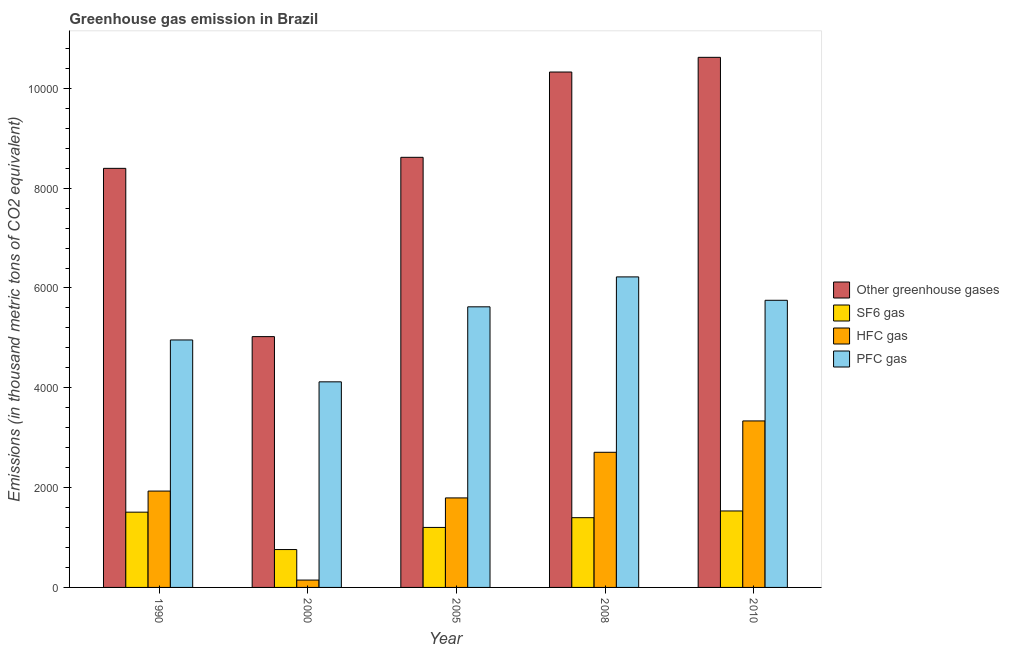How many different coloured bars are there?
Offer a terse response. 4. Are the number of bars per tick equal to the number of legend labels?
Ensure brevity in your answer.  Yes. What is the label of the 3rd group of bars from the left?
Your answer should be very brief. 2005. What is the emission of sf6 gas in 2010?
Your answer should be very brief. 1532. Across all years, what is the maximum emission of hfc gas?
Ensure brevity in your answer.  3336. Across all years, what is the minimum emission of pfc gas?
Your response must be concise. 4119.1. In which year was the emission of sf6 gas maximum?
Your answer should be compact. 2010. In which year was the emission of pfc gas minimum?
Ensure brevity in your answer.  2000. What is the total emission of hfc gas in the graph?
Keep it short and to the point. 9915. What is the difference between the emission of greenhouse gases in 2005 and that in 2008?
Keep it short and to the point. -1709.1. What is the difference between the emission of pfc gas in 1990 and the emission of greenhouse gases in 2000?
Provide a succinct answer. 839. What is the average emission of greenhouse gases per year?
Your answer should be compact. 8597.4. What is the ratio of the emission of hfc gas in 2008 to that in 2010?
Ensure brevity in your answer.  0.81. Is the difference between the emission of hfc gas in 1990 and 2008 greater than the difference between the emission of sf6 gas in 1990 and 2008?
Your response must be concise. No. What is the difference between the highest and the second highest emission of greenhouse gases?
Provide a short and direct response. 294.4. What is the difference between the highest and the lowest emission of sf6 gas?
Ensure brevity in your answer.  773.3. Is it the case that in every year, the sum of the emission of greenhouse gases and emission of hfc gas is greater than the sum of emission of pfc gas and emission of sf6 gas?
Keep it short and to the point. Yes. What does the 2nd bar from the left in 2008 represents?
Offer a terse response. SF6 gas. What does the 2nd bar from the right in 1990 represents?
Offer a very short reply. HFC gas. Is it the case that in every year, the sum of the emission of greenhouse gases and emission of sf6 gas is greater than the emission of hfc gas?
Your answer should be very brief. Yes. How many years are there in the graph?
Give a very brief answer. 5. What is the difference between two consecutive major ticks on the Y-axis?
Give a very brief answer. 2000. Are the values on the major ticks of Y-axis written in scientific E-notation?
Provide a short and direct response. No. Does the graph contain grids?
Offer a very short reply. No. Where does the legend appear in the graph?
Provide a succinct answer. Center right. How are the legend labels stacked?
Your answer should be very brief. Vertical. What is the title of the graph?
Your response must be concise. Greenhouse gas emission in Brazil. Does "Taxes on revenue" appear as one of the legend labels in the graph?
Your answer should be compact. No. What is the label or title of the Y-axis?
Provide a short and direct response. Emissions (in thousand metric tons of CO2 equivalent). What is the Emissions (in thousand metric tons of CO2 equivalent) of Other greenhouse gases in 1990?
Your answer should be very brief. 8396.7. What is the Emissions (in thousand metric tons of CO2 equivalent) of SF6 gas in 1990?
Offer a very short reply. 1507.9. What is the Emissions (in thousand metric tons of CO2 equivalent) of HFC gas in 1990?
Your answer should be compact. 1930.7. What is the Emissions (in thousand metric tons of CO2 equivalent) in PFC gas in 1990?
Your answer should be compact. 4958.1. What is the Emissions (in thousand metric tons of CO2 equivalent) of Other greenhouse gases in 2000?
Give a very brief answer. 5025.2. What is the Emissions (in thousand metric tons of CO2 equivalent) in SF6 gas in 2000?
Keep it short and to the point. 758.7. What is the Emissions (in thousand metric tons of CO2 equivalent) in HFC gas in 2000?
Your answer should be compact. 147.4. What is the Emissions (in thousand metric tons of CO2 equivalent) in PFC gas in 2000?
Your answer should be very brief. 4119.1. What is the Emissions (in thousand metric tons of CO2 equivalent) in Other greenhouse gases in 2005?
Your answer should be compact. 8617.5. What is the Emissions (in thousand metric tons of CO2 equivalent) of SF6 gas in 2005?
Your answer should be compact. 1202. What is the Emissions (in thousand metric tons of CO2 equivalent) in HFC gas in 2005?
Your answer should be compact. 1793.4. What is the Emissions (in thousand metric tons of CO2 equivalent) in PFC gas in 2005?
Provide a short and direct response. 5622.1. What is the Emissions (in thousand metric tons of CO2 equivalent) of Other greenhouse gases in 2008?
Give a very brief answer. 1.03e+04. What is the Emissions (in thousand metric tons of CO2 equivalent) of SF6 gas in 2008?
Your answer should be very brief. 1397.3. What is the Emissions (in thousand metric tons of CO2 equivalent) in HFC gas in 2008?
Your answer should be compact. 2707.5. What is the Emissions (in thousand metric tons of CO2 equivalent) of PFC gas in 2008?
Provide a succinct answer. 6221.8. What is the Emissions (in thousand metric tons of CO2 equivalent) in Other greenhouse gases in 2010?
Offer a very short reply. 1.06e+04. What is the Emissions (in thousand metric tons of CO2 equivalent) of SF6 gas in 2010?
Your response must be concise. 1532. What is the Emissions (in thousand metric tons of CO2 equivalent) of HFC gas in 2010?
Keep it short and to the point. 3336. What is the Emissions (in thousand metric tons of CO2 equivalent) in PFC gas in 2010?
Provide a short and direct response. 5753. Across all years, what is the maximum Emissions (in thousand metric tons of CO2 equivalent) in Other greenhouse gases?
Provide a succinct answer. 1.06e+04. Across all years, what is the maximum Emissions (in thousand metric tons of CO2 equivalent) of SF6 gas?
Keep it short and to the point. 1532. Across all years, what is the maximum Emissions (in thousand metric tons of CO2 equivalent) in HFC gas?
Offer a terse response. 3336. Across all years, what is the maximum Emissions (in thousand metric tons of CO2 equivalent) in PFC gas?
Your answer should be compact. 6221.8. Across all years, what is the minimum Emissions (in thousand metric tons of CO2 equivalent) in Other greenhouse gases?
Provide a short and direct response. 5025.2. Across all years, what is the minimum Emissions (in thousand metric tons of CO2 equivalent) of SF6 gas?
Offer a very short reply. 758.7. Across all years, what is the minimum Emissions (in thousand metric tons of CO2 equivalent) in HFC gas?
Your response must be concise. 147.4. Across all years, what is the minimum Emissions (in thousand metric tons of CO2 equivalent) in PFC gas?
Keep it short and to the point. 4119.1. What is the total Emissions (in thousand metric tons of CO2 equivalent) of Other greenhouse gases in the graph?
Make the answer very short. 4.30e+04. What is the total Emissions (in thousand metric tons of CO2 equivalent) of SF6 gas in the graph?
Offer a terse response. 6397.9. What is the total Emissions (in thousand metric tons of CO2 equivalent) of HFC gas in the graph?
Offer a very short reply. 9915. What is the total Emissions (in thousand metric tons of CO2 equivalent) of PFC gas in the graph?
Provide a succinct answer. 2.67e+04. What is the difference between the Emissions (in thousand metric tons of CO2 equivalent) of Other greenhouse gases in 1990 and that in 2000?
Provide a short and direct response. 3371.5. What is the difference between the Emissions (in thousand metric tons of CO2 equivalent) of SF6 gas in 1990 and that in 2000?
Give a very brief answer. 749.2. What is the difference between the Emissions (in thousand metric tons of CO2 equivalent) in HFC gas in 1990 and that in 2000?
Give a very brief answer. 1783.3. What is the difference between the Emissions (in thousand metric tons of CO2 equivalent) of PFC gas in 1990 and that in 2000?
Provide a succinct answer. 839. What is the difference between the Emissions (in thousand metric tons of CO2 equivalent) of Other greenhouse gases in 1990 and that in 2005?
Your answer should be compact. -220.8. What is the difference between the Emissions (in thousand metric tons of CO2 equivalent) of SF6 gas in 1990 and that in 2005?
Ensure brevity in your answer.  305.9. What is the difference between the Emissions (in thousand metric tons of CO2 equivalent) in HFC gas in 1990 and that in 2005?
Offer a very short reply. 137.3. What is the difference between the Emissions (in thousand metric tons of CO2 equivalent) of PFC gas in 1990 and that in 2005?
Keep it short and to the point. -664. What is the difference between the Emissions (in thousand metric tons of CO2 equivalent) of Other greenhouse gases in 1990 and that in 2008?
Make the answer very short. -1929.9. What is the difference between the Emissions (in thousand metric tons of CO2 equivalent) of SF6 gas in 1990 and that in 2008?
Offer a terse response. 110.6. What is the difference between the Emissions (in thousand metric tons of CO2 equivalent) of HFC gas in 1990 and that in 2008?
Your answer should be very brief. -776.8. What is the difference between the Emissions (in thousand metric tons of CO2 equivalent) in PFC gas in 1990 and that in 2008?
Offer a terse response. -1263.7. What is the difference between the Emissions (in thousand metric tons of CO2 equivalent) in Other greenhouse gases in 1990 and that in 2010?
Provide a succinct answer. -2224.3. What is the difference between the Emissions (in thousand metric tons of CO2 equivalent) in SF6 gas in 1990 and that in 2010?
Your answer should be compact. -24.1. What is the difference between the Emissions (in thousand metric tons of CO2 equivalent) in HFC gas in 1990 and that in 2010?
Make the answer very short. -1405.3. What is the difference between the Emissions (in thousand metric tons of CO2 equivalent) of PFC gas in 1990 and that in 2010?
Make the answer very short. -794.9. What is the difference between the Emissions (in thousand metric tons of CO2 equivalent) in Other greenhouse gases in 2000 and that in 2005?
Ensure brevity in your answer.  -3592.3. What is the difference between the Emissions (in thousand metric tons of CO2 equivalent) in SF6 gas in 2000 and that in 2005?
Offer a very short reply. -443.3. What is the difference between the Emissions (in thousand metric tons of CO2 equivalent) in HFC gas in 2000 and that in 2005?
Offer a terse response. -1646. What is the difference between the Emissions (in thousand metric tons of CO2 equivalent) in PFC gas in 2000 and that in 2005?
Offer a very short reply. -1503. What is the difference between the Emissions (in thousand metric tons of CO2 equivalent) in Other greenhouse gases in 2000 and that in 2008?
Your response must be concise. -5301.4. What is the difference between the Emissions (in thousand metric tons of CO2 equivalent) in SF6 gas in 2000 and that in 2008?
Keep it short and to the point. -638.6. What is the difference between the Emissions (in thousand metric tons of CO2 equivalent) of HFC gas in 2000 and that in 2008?
Provide a short and direct response. -2560.1. What is the difference between the Emissions (in thousand metric tons of CO2 equivalent) of PFC gas in 2000 and that in 2008?
Your response must be concise. -2102.7. What is the difference between the Emissions (in thousand metric tons of CO2 equivalent) of Other greenhouse gases in 2000 and that in 2010?
Your answer should be very brief. -5595.8. What is the difference between the Emissions (in thousand metric tons of CO2 equivalent) of SF6 gas in 2000 and that in 2010?
Make the answer very short. -773.3. What is the difference between the Emissions (in thousand metric tons of CO2 equivalent) in HFC gas in 2000 and that in 2010?
Ensure brevity in your answer.  -3188.6. What is the difference between the Emissions (in thousand metric tons of CO2 equivalent) in PFC gas in 2000 and that in 2010?
Ensure brevity in your answer.  -1633.9. What is the difference between the Emissions (in thousand metric tons of CO2 equivalent) of Other greenhouse gases in 2005 and that in 2008?
Your answer should be compact. -1709.1. What is the difference between the Emissions (in thousand metric tons of CO2 equivalent) in SF6 gas in 2005 and that in 2008?
Ensure brevity in your answer.  -195.3. What is the difference between the Emissions (in thousand metric tons of CO2 equivalent) in HFC gas in 2005 and that in 2008?
Ensure brevity in your answer.  -914.1. What is the difference between the Emissions (in thousand metric tons of CO2 equivalent) of PFC gas in 2005 and that in 2008?
Your answer should be compact. -599.7. What is the difference between the Emissions (in thousand metric tons of CO2 equivalent) in Other greenhouse gases in 2005 and that in 2010?
Offer a terse response. -2003.5. What is the difference between the Emissions (in thousand metric tons of CO2 equivalent) in SF6 gas in 2005 and that in 2010?
Your answer should be very brief. -330. What is the difference between the Emissions (in thousand metric tons of CO2 equivalent) of HFC gas in 2005 and that in 2010?
Give a very brief answer. -1542.6. What is the difference between the Emissions (in thousand metric tons of CO2 equivalent) in PFC gas in 2005 and that in 2010?
Keep it short and to the point. -130.9. What is the difference between the Emissions (in thousand metric tons of CO2 equivalent) of Other greenhouse gases in 2008 and that in 2010?
Your response must be concise. -294.4. What is the difference between the Emissions (in thousand metric tons of CO2 equivalent) of SF6 gas in 2008 and that in 2010?
Your answer should be compact. -134.7. What is the difference between the Emissions (in thousand metric tons of CO2 equivalent) in HFC gas in 2008 and that in 2010?
Your answer should be compact. -628.5. What is the difference between the Emissions (in thousand metric tons of CO2 equivalent) in PFC gas in 2008 and that in 2010?
Keep it short and to the point. 468.8. What is the difference between the Emissions (in thousand metric tons of CO2 equivalent) in Other greenhouse gases in 1990 and the Emissions (in thousand metric tons of CO2 equivalent) in SF6 gas in 2000?
Your answer should be very brief. 7638. What is the difference between the Emissions (in thousand metric tons of CO2 equivalent) of Other greenhouse gases in 1990 and the Emissions (in thousand metric tons of CO2 equivalent) of HFC gas in 2000?
Your answer should be compact. 8249.3. What is the difference between the Emissions (in thousand metric tons of CO2 equivalent) in Other greenhouse gases in 1990 and the Emissions (in thousand metric tons of CO2 equivalent) in PFC gas in 2000?
Keep it short and to the point. 4277.6. What is the difference between the Emissions (in thousand metric tons of CO2 equivalent) of SF6 gas in 1990 and the Emissions (in thousand metric tons of CO2 equivalent) of HFC gas in 2000?
Your response must be concise. 1360.5. What is the difference between the Emissions (in thousand metric tons of CO2 equivalent) of SF6 gas in 1990 and the Emissions (in thousand metric tons of CO2 equivalent) of PFC gas in 2000?
Offer a terse response. -2611.2. What is the difference between the Emissions (in thousand metric tons of CO2 equivalent) in HFC gas in 1990 and the Emissions (in thousand metric tons of CO2 equivalent) in PFC gas in 2000?
Ensure brevity in your answer.  -2188.4. What is the difference between the Emissions (in thousand metric tons of CO2 equivalent) of Other greenhouse gases in 1990 and the Emissions (in thousand metric tons of CO2 equivalent) of SF6 gas in 2005?
Keep it short and to the point. 7194.7. What is the difference between the Emissions (in thousand metric tons of CO2 equivalent) of Other greenhouse gases in 1990 and the Emissions (in thousand metric tons of CO2 equivalent) of HFC gas in 2005?
Ensure brevity in your answer.  6603.3. What is the difference between the Emissions (in thousand metric tons of CO2 equivalent) of Other greenhouse gases in 1990 and the Emissions (in thousand metric tons of CO2 equivalent) of PFC gas in 2005?
Your response must be concise. 2774.6. What is the difference between the Emissions (in thousand metric tons of CO2 equivalent) in SF6 gas in 1990 and the Emissions (in thousand metric tons of CO2 equivalent) in HFC gas in 2005?
Your answer should be compact. -285.5. What is the difference between the Emissions (in thousand metric tons of CO2 equivalent) of SF6 gas in 1990 and the Emissions (in thousand metric tons of CO2 equivalent) of PFC gas in 2005?
Your answer should be compact. -4114.2. What is the difference between the Emissions (in thousand metric tons of CO2 equivalent) in HFC gas in 1990 and the Emissions (in thousand metric tons of CO2 equivalent) in PFC gas in 2005?
Your answer should be very brief. -3691.4. What is the difference between the Emissions (in thousand metric tons of CO2 equivalent) in Other greenhouse gases in 1990 and the Emissions (in thousand metric tons of CO2 equivalent) in SF6 gas in 2008?
Your answer should be compact. 6999.4. What is the difference between the Emissions (in thousand metric tons of CO2 equivalent) in Other greenhouse gases in 1990 and the Emissions (in thousand metric tons of CO2 equivalent) in HFC gas in 2008?
Offer a terse response. 5689.2. What is the difference between the Emissions (in thousand metric tons of CO2 equivalent) of Other greenhouse gases in 1990 and the Emissions (in thousand metric tons of CO2 equivalent) of PFC gas in 2008?
Make the answer very short. 2174.9. What is the difference between the Emissions (in thousand metric tons of CO2 equivalent) in SF6 gas in 1990 and the Emissions (in thousand metric tons of CO2 equivalent) in HFC gas in 2008?
Your answer should be very brief. -1199.6. What is the difference between the Emissions (in thousand metric tons of CO2 equivalent) in SF6 gas in 1990 and the Emissions (in thousand metric tons of CO2 equivalent) in PFC gas in 2008?
Ensure brevity in your answer.  -4713.9. What is the difference between the Emissions (in thousand metric tons of CO2 equivalent) in HFC gas in 1990 and the Emissions (in thousand metric tons of CO2 equivalent) in PFC gas in 2008?
Offer a very short reply. -4291.1. What is the difference between the Emissions (in thousand metric tons of CO2 equivalent) in Other greenhouse gases in 1990 and the Emissions (in thousand metric tons of CO2 equivalent) in SF6 gas in 2010?
Keep it short and to the point. 6864.7. What is the difference between the Emissions (in thousand metric tons of CO2 equivalent) in Other greenhouse gases in 1990 and the Emissions (in thousand metric tons of CO2 equivalent) in HFC gas in 2010?
Your answer should be very brief. 5060.7. What is the difference between the Emissions (in thousand metric tons of CO2 equivalent) in Other greenhouse gases in 1990 and the Emissions (in thousand metric tons of CO2 equivalent) in PFC gas in 2010?
Offer a very short reply. 2643.7. What is the difference between the Emissions (in thousand metric tons of CO2 equivalent) in SF6 gas in 1990 and the Emissions (in thousand metric tons of CO2 equivalent) in HFC gas in 2010?
Offer a very short reply. -1828.1. What is the difference between the Emissions (in thousand metric tons of CO2 equivalent) of SF6 gas in 1990 and the Emissions (in thousand metric tons of CO2 equivalent) of PFC gas in 2010?
Provide a succinct answer. -4245.1. What is the difference between the Emissions (in thousand metric tons of CO2 equivalent) of HFC gas in 1990 and the Emissions (in thousand metric tons of CO2 equivalent) of PFC gas in 2010?
Your answer should be very brief. -3822.3. What is the difference between the Emissions (in thousand metric tons of CO2 equivalent) in Other greenhouse gases in 2000 and the Emissions (in thousand metric tons of CO2 equivalent) in SF6 gas in 2005?
Offer a very short reply. 3823.2. What is the difference between the Emissions (in thousand metric tons of CO2 equivalent) in Other greenhouse gases in 2000 and the Emissions (in thousand metric tons of CO2 equivalent) in HFC gas in 2005?
Give a very brief answer. 3231.8. What is the difference between the Emissions (in thousand metric tons of CO2 equivalent) of Other greenhouse gases in 2000 and the Emissions (in thousand metric tons of CO2 equivalent) of PFC gas in 2005?
Offer a very short reply. -596.9. What is the difference between the Emissions (in thousand metric tons of CO2 equivalent) of SF6 gas in 2000 and the Emissions (in thousand metric tons of CO2 equivalent) of HFC gas in 2005?
Provide a short and direct response. -1034.7. What is the difference between the Emissions (in thousand metric tons of CO2 equivalent) in SF6 gas in 2000 and the Emissions (in thousand metric tons of CO2 equivalent) in PFC gas in 2005?
Make the answer very short. -4863.4. What is the difference between the Emissions (in thousand metric tons of CO2 equivalent) in HFC gas in 2000 and the Emissions (in thousand metric tons of CO2 equivalent) in PFC gas in 2005?
Provide a succinct answer. -5474.7. What is the difference between the Emissions (in thousand metric tons of CO2 equivalent) of Other greenhouse gases in 2000 and the Emissions (in thousand metric tons of CO2 equivalent) of SF6 gas in 2008?
Your response must be concise. 3627.9. What is the difference between the Emissions (in thousand metric tons of CO2 equivalent) of Other greenhouse gases in 2000 and the Emissions (in thousand metric tons of CO2 equivalent) of HFC gas in 2008?
Provide a short and direct response. 2317.7. What is the difference between the Emissions (in thousand metric tons of CO2 equivalent) in Other greenhouse gases in 2000 and the Emissions (in thousand metric tons of CO2 equivalent) in PFC gas in 2008?
Your answer should be compact. -1196.6. What is the difference between the Emissions (in thousand metric tons of CO2 equivalent) of SF6 gas in 2000 and the Emissions (in thousand metric tons of CO2 equivalent) of HFC gas in 2008?
Make the answer very short. -1948.8. What is the difference between the Emissions (in thousand metric tons of CO2 equivalent) of SF6 gas in 2000 and the Emissions (in thousand metric tons of CO2 equivalent) of PFC gas in 2008?
Your response must be concise. -5463.1. What is the difference between the Emissions (in thousand metric tons of CO2 equivalent) in HFC gas in 2000 and the Emissions (in thousand metric tons of CO2 equivalent) in PFC gas in 2008?
Offer a very short reply. -6074.4. What is the difference between the Emissions (in thousand metric tons of CO2 equivalent) of Other greenhouse gases in 2000 and the Emissions (in thousand metric tons of CO2 equivalent) of SF6 gas in 2010?
Give a very brief answer. 3493.2. What is the difference between the Emissions (in thousand metric tons of CO2 equivalent) of Other greenhouse gases in 2000 and the Emissions (in thousand metric tons of CO2 equivalent) of HFC gas in 2010?
Offer a terse response. 1689.2. What is the difference between the Emissions (in thousand metric tons of CO2 equivalent) of Other greenhouse gases in 2000 and the Emissions (in thousand metric tons of CO2 equivalent) of PFC gas in 2010?
Give a very brief answer. -727.8. What is the difference between the Emissions (in thousand metric tons of CO2 equivalent) in SF6 gas in 2000 and the Emissions (in thousand metric tons of CO2 equivalent) in HFC gas in 2010?
Offer a very short reply. -2577.3. What is the difference between the Emissions (in thousand metric tons of CO2 equivalent) in SF6 gas in 2000 and the Emissions (in thousand metric tons of CO2 equivalent) in PFC gas in 2010?
Keep it short and to the point. -4994.3. What is the difference between the Emissions (in thousand metric tons of CO2 equivalent) in HFC gas in 2000 and the Emissions (in thousand metric tons of CO2 equivalent) in PFC gas in 2010?
Your answer should be compact. -5605.6. What is the difference between the Emissions (in thousand metric tons of CO2 equivalent) in Other greenhouse gases in 2005 and the Emissions (in thousand metric tons of CO2 equivalent) in SF6 gas in 2008?
Offer a terse response. 7220.2. What is the difference between the Emissions (in thousand metric tons of CO2 equivalent) in Other greenhouse gases in 2005 and the Emissions (in thousand metric tons of CO2 equivalent) in HFC gas in 2008?
Offer a very short reply. 5910. What is the difference between the Emissions (in thousand metric tons of CO2 equivalent) of Other greenhouse gases in 2005 and the Emissions (in thousand metric tons of CO2 equivalent) of PFC gas in 2008?
Ensure brevity in your answer.  2395.7. What is the difference between the Emissions (in thousand metric tons of CO2 equivalent) of SF6 gas in 2005 and the Emissions (in thousand metric tons of CO2 equivalent) of HFC gas in 2008?
Your response must be concise. -1505.5. What is the difference between the Emissions (in thousand metric tons of CO2 equivalent) in SF6 gas in 2005 and the Emissions (in thousand metric tons of CO2 equivalent) in PFC gas in 2008?
Ensure brevity in your answer.  -5019.8. What is the difference between the Emissions (in thousand metric tons of CO2 equivalent) in HFC gas in 2005 and the Emissions (in thousand metric tons of CO2 equivalent) in PFC gas in 2008?
Make the answer very short. -4428.4. What is the difference between the Emissions (in thousand metric tons of CO2 equivalent) in Other greenhouse gases in 2005 and the Emissions (in thousand metric tons of CO2 equivalent) in SF6 gas in 2010?
Offer a very short reply. 7085.5. What is the difference between the Emissions (in thousand metric tons of CO2 equivalent) in Other greenhouse gases in 2005 and the Emissions (in thousand metric tons of CO2 equivalent) in HFC gas in 2010?
Provide a short and direct response. 5281.5. What is the difference between the Emissions (in thousand metric tons of CO2 equivalent) of Other greenhouse gases in 2005 and the Emissions (in thousand metric tons of CO2 equivalent) of PFC gas in 2010?
Ensure brevity in your answer.  2864.5. What is the difference between the Emissions (in thousand metric tons of CO2 equivalent) of SF6 gas in 2005 and the Emissions (in thousand metric tons of CO2 equivalent) of HFC gas in 2010?
Make the answer very short. -2134. What is the difference between the Emissions (in thousand metric tons of CO2 equivalent) of SF6 gas in 2005 and the Emissions (in thousand metric tons of CO2 equivalent) of PFC gas in 2010?
Your answer should be compact. -4551. What is the difference between the Emissions (in thousand metric tons of CO2 equivalent) of HFC gas in 2005 and the Emissions (in thousand metric tons of CO2 equivalent) of PFC gas in 2010?
Keep it short and to the point. -3959.6. What is the difference between the Emissions (in thousand metric tons of CO2 equivalent) of Other greenhouse gases in 2008 and the Emissions (in thousand metric tons of CO2 equivalent) of SF6 gas in 2010?
Ensure brevity in your answer.  8794.6. What is the difference between the Emissions (in thousand metric tons of CO2 equivalent) of Other greenhouse gases in 2008 and the Emissions (in thousand metric tons of CO2 equivalent) of HFC gas in 2010?
Ensure brevity in your answer.  6990.6. What is the difference between the Emissions (in thousand metric tons of CO2 equivalent) in Other greenhouse gases in 2008 and the Emissions (in thousand metric tons of CO2 equivalent) in PFC gas in 2010?
Your response must be concise. 4573.6. What is the difference between the Emissions (in thousand metric tons of CO2 equivalent) of SF6 gas in 2008 and the Emissions (in thousand metric tons of CO2 equivalent) of HFC gas in 2010?
Ensure brevity in your answer.  -1938.7. What is the difference between the Emissions (in thousand metric tons of CO2 equivalent) in SF6 gas in 2008 and the Emissions (in thousand metric tons of CO2 equivalent) in PFC gas in 2010?
Your response must be concise. -4355.7. What is the difference between the Emissions (in thousand metric tons of CO2 equivalent) of HFC gas in 2008 and the Emissions (in thousand metric tons of CO2 equivalent) of PFC gas in 2010?
Ensure brevity in your answer.  -3045.5. What is the average Emissions (in thousand metric tons of CO2 equivalent) in Other greenhouse gases per year?
Your response must be concise. 8597.4. What is the average Emissions (in thousand metric tons of CO2 equivalent) of SF6 gas per year?
Offer a terse response. 1279.58. What is the average Emissions (in thousand metric tons of CO2 equivalent) in HFC gas per year?
Give a very brief answer. 1983. What is the average Emissions (in thousand metric tons of CO2 equivalent) of PFC gas per year?
Your response must be concise. 5334.82. In the year 1990, what is the difference between the Emissions (in thousand metric tons of CO2 equivalent) in Other greenhouse gases and Emissions (in thousand metric tons of CO2 equivalent) in SF6 gas?
Give a very brief answer. 6888.8. In the year 1990, what is the difference between the Emissions (in thousand metric tons of CO2 equivalent) in Other greenhouse gases and Emissions (in thousand metric tons of CO2 equivalent) in HFC gas?
Offer a very short reply. 6466. In the year 1990, what is the difference between the Emissions (in thousand metric tons of CO2 equivalent) in Other greenhouse gases and Emissions (in thousand metric tons of CO2 equivalent) in PFC gas?
Provide a short and direct response. 3438.6. In the year 1990, what is the difference between the Emissions (in thousand metric tons of CO2 equivalent) in SF6 gas and Emissions (in thousand metric tons of CO2 equivalent) in HFC gas?
Your answer should be compact. -422.8. In the year 1990, what is the difference between the Emissions (in thousand metric tons of CO2 equivalent) in SF6 gas and Emissions (in thousand metric tons of CO2 equivalent) in PFC gas?
Your response must be concise. -3450.2. In the year 1990, what is the difference between the Emissions (in thousand metric tons of CO2 equivalent) in HFC gas and Emissions (in thousand metric tons of CO2 equivalent) in PFC gas?
Your answer should be very brief. -3027.4. In the year 2000, what is the difference between the Emissions (in thousand metric tons of CO2 equivalent) in Other greenhouse gases and Emissions (in thousand metric tons of CO2 equivalent) in SF6 gas?
Make the answer very short. 4266.5. In the year 2000, what is the difference between the Emissions (in thousand metric tons of CO2 equivalent) in Other greenhouse gases and Emissions (in thousand metric tons of CO2 equivalent) in HFC gas?
Keep it short and to the point. 4877.8. In the year 2000, what is the difference between the Emissions (in thousand metric tons of CO2 equivalent) in Other greenhouse gases and Emissions (in thousand metric tons of CO2 equivalent) in PFC gas?
Make the answer very short. 906.1. In the year 2000, what is the difference between the Emissions (in thousand metric tons of CO2 equivalent) in SF6 gas and Emissions (in thousand metric tons of CO2 equivalent) in HFC gas?
Ensure brevity in your answer.  611.3. In the year 2000, what is the difference between the Emissions (in thousand metric tons of CO2 equivalent) of SF6 gas and Emissions (in thousand metric tons of CO2 equivalent) of PFC gas?
Your answer should be compact. -3360.4. In the year 2000, what is the difference between the Emissions (in thousand metric tons of CO2 equivalent) of HFC gas and Emissions (in thousand metric tons of CO2 equivalent) of PFC gas?
Keep it short and to the point. -3971.7. In the year 2005, what is the difference between the Emissions (in thousand metric tons of CO2 equivalent) in Other greenhouse gases and Emissions (in thousand metric tons of CO2 equivalent) in SF6 gas?
Give a very brief answer. 7415.5. In the year 2005, what is the difference between the Emissions (in thousand metric tons of CO2 equivalent) in Other greenhouse gases and Emissions (in thousand metric tons of CO2 equivalent) in HFC gas?
Provide a short and direct response. 6824.1. In the year 2005, what is the difference between the Emissions (in thousand metric tons of CO2 equivalent) of Other greenhouse gases and Emissions (in thousand metric tons of CO2 equivalent) of PFC gas?
Provide a succinct answer. 2995.4. In the year 2005, what is the difference between the Emissions (in thousand metric tons of CO2 equivalent) in SF6 gas and Emissions (in thousand metric tons of CO2 equivalent) in HFC gas?
Ensure brevity in your answer.  -591.4. In the year 2005, what is the difference between the Emissions (in thousand metric tons of CO2 equivalent) of SF6 gas and Emissions (in thousand metric tons of CO2 equivalent) of PFC gas?
Your response must be concise. -4420.1. In the year 2005, what is the difference between the Emissions (in thousand metric tons of CO2 equivalent) of HFC gas and Emissions (in thousand metric tons of CO2 equivalent) of PFC gas?
Provide a short and direct response. -3828.7. In the year 2008, what is the difference between the Emissions (in thousand metric tons of CO2 equivalent) of Other greenhouse gases and Emissions (in thousand metric tons of CO2 equivalent) of SF6 gas?
Give a very brief answer. 8929.3. In the year 2008, what is the difference between the Emissions (in thousand metric tons of CO2 equivalent) of Other greenhouse gases and Emissions (in thousand metric tons of CO2 equivalent) of HFC gas?
Give a very brief answer. 7619.1. In the year 2008, what is the difference between the Emissions (in thousand metric tons of CO2 equivalent) in Other greenhouse gases and Emissions (in thousand metric tons of CO2 equivalent) in PFC gas?
Your answer should be compact. 4104.8. In the year 2008, what is the difference between the Emissions (in thousand metric tons of CO2 equivalent) of SF6 gas and Emissions (in thousand metric tons of CO2 equivalent) of HFC gas?
Your response must be concise. -1310.2. In the year 2008, what is the difference between the Emissions (in thousand metric tons of CO2 equivalent) in SF6 gas and Emissions (in thousand metric tons of CO2 equivalent) in PFC gas?
Provide a succinct answer. -4824.5. In the year 2008, what is the difference between the Emissions (in thousand metric tons of CO2 equivalent) in HFC gas and Emissions (in thousand metric tons of CO2 equivalent) in PFC gas?
Your answer should be very brief. -3514.3. In the year 2010, what is the difference between the Emissions (in thousand metric tons of CO2 equivalent) in Other greenhouse gases and Emissions (in thousand metric tons of CO2 equivalent) in SF6 gas?
Ensure brevity in your answer.  9089. In the year 2010, what is the difference between the Emissions (in thousand metric tons of CO2 equivalent) of Other greenhouse gases and Emissions (in thousand metric tons of CO2 equivalent) of HFC gas?
Your response must be concise. 7285. In the year 2010, what is the difference between the Emissions (in thousand metric tons of CO2 equivalent) in Other greenhouse gases and Emissions (in thousand metric tons of CO2 equivalent) in PFC gas?
Ensure brevity in your answer.  4868. In the year 2010, what is the difference between the Emissions (in thousand metric tons of CO2 equivalent) in SF6 gas and Emissions (in thousand metric tons of CO2 equivalent) in HFC gas?
Offer a terse response. -1804. In the year 2010, what is the difference between the Emissions (in thousand metric tons of CO2 equivalent) in SF6 gas and Emissions (in thousand metric tons of CO2 equivalent) in PFC gas?
Your answer should be compact. -4221. In the year 2010, what is the difference between the Emissions (in thousand metric tons of CO2 equivalent) of HFC gas and Emissions (in thousand metric tons of CO2 equivalent) of PFC gas?
Your response must be concise. -2417. What is the ratio of the Emissions (in thousand metric tons of CO2 equivalent) in Other greenhouse gases in 1990 to that in 2000?
Keep it short and to the point. 1.67. What is the ratio of the Emissions (in thousand metric tons of CO2 equivalent) of SF6 gas in 1990 to that in 2000?
Your answer should be compact. 1.99. What is the ratio of the Emissions (in thousand metric tons of CO2 equivalent) of HFC gas in 1990 to that in 2000?
Give a very brief answer. 13.1. What is the ratio of the Emissions (in thousand metric tons of CO2 equivalent) of PFC gas in 1990 to that in 2000?
Your response must be concise. 1.2. What is the ratio of the Emissions (in thousand metric tons of CO2 equivalent) in Other greenhouse gases in 1990 to that in 2005?
Make the answer very short. 0.97. What is the ratio of the Emissions (in thousand metric tons of CO2 equivalent) in SF6 gas in 1990 to that in 2005?
Provide a succinct answer. 1.25. What is the ratio of the Emissions (in thousand metric tons of CO2 equivalent) in HFC gas in 1990 to that in 2005?
Make the answer very short. 1.08. What is the ratio of the Emissions (in thousand metric tons of CO2 equivalent) in PFC gas in 1990 to that in 2005?
Offer a terse response. 0.88. What is the ratio of the Emissions (in thousand metric tons of CO2 equivalent) of Other greenhouse gases in 1990 to that in 2008?
Provide a succinct answer. 0.81. What is the ratio of the Emissions (in thousand metric tons of CO2 equivalent) in SF6 gas in 1990 to that in 2008?
Make the answer very short. 1.08. What is the ratio of the Emissions (in thousand metric tons of CO2 equivalent) in HFC gas in 1990 to that in 2008?
Make the answer very short. 0.71. What is the ratio of the Emissions (in thousand metric tons of CO2 equivalent) of PFC gas in 1990 to that in 2008?
Your response must be concise. 0.8. What is the ratio of the Emissions (in thousand metric tons of CO2 equivalent) in Other greenhouse gases in 1990 to that in 2010?
Give a very brief answer. 0.79. What is the ratio of the Emissions (in thousand metric tons of CO2 equivalent) of SF6 gas in 1990 to that in 2010?
Ensure brevity in your answer.  0.98. What is the ratio of the Emissions (in thousand metric tons of CO2 equivalent) in HFC gas in 1990 to that in 2010?
Keep it short and to the point. 0.58. What is the ratio of the Emissions (in thousand metric tons of CO2 equivalent) of PFC gas in 1990 to that in 2010?
Offer a terse response. 0.86. What is the ratio of the Emissions (in thousand metric tons of CO2 equivalent) of Other greenhouse gases in 2000 to that in 2005?
Your answer should be compact. 0.58. What is the ratio of the Emissions (in thousand metric tons of CO2 equivalent) in SF6 gas in 2000 to that in 2005?
Your answer should be compact. 0.63. What is the ratio of the Emissions (in thousand metric tons of CO2 equivalent) in HFC gas in 2000 to that in 2005?
Provide a short and direct response. 0.08. What is the ratio of the Emissions (in thousand metric tons of CO2 equivalent) of PFC gas in 2000 to that in 2005?
Offer a very short reply. 0.73. What is the ratio of the Emissions (in thousand metric tons of CO2 equivalent) in Other greenhouse gases in 2000 to that in 2008?
Your response must be concise. 0.49. What is the ratio of the Emissions (in thousand metric tons of CO2 equivalent) of SF6 gas in 2000 to that in 2008?
Make the answer very short. 0.54. What is the ratio of the Emissions (in thousand metric tons of CO2 equivalent) in HFC gas in 2000 to that in 2008?
Make the answer very short. 0.05. What is the ratio of the Emissions (in thousand metric tons of CO2 equivalent) of PFC gas in 2000 to that in 2008?
Keep it short and to the point. 0.66. What is the ratio of the Emissions (in thousand metric tons of CO2 equivalent) of Other greenhouse gases in 2000 to that in 2010?
Give a very brief answer. 0.47. What is the ratio of the Emissions (in thousand metric tons of CO2 equivalent) in SF6 gas in 2000 to that in 2010?
Your answer should be very brief. 0.5. What is the ratio of the Emissions (in thousand metric tons of CO2 equivalent) in HFC gas in 2000 to that in 2010?
Give a very brief answer. 0.04. What is the ratio of the Emissions (in thousand metric tons of CO2 equivalent) of PFC gas in 2000 to that in 2010?
Give a very brief answer. 0.72. What is the ratio of the Emissions (in thousand metric tons of CO2 equivalent) of Other greenhouse gases in 2005 to that in 2008?
Give a very brief answer. 0.83. What is the ratio of the Emissions (in thousand metric tons of CO2 equivalent) in SF6 gas in 2005 to that in 2008?
Provide a succinct answer. 0.86. What is the ratio of the Emissions (in thousand metric tons of CO2 equivalent) of HFC gas in 2005 to that in 2008?
Make the answer very short. 0.66. What is the ratio of the Emissions (in thousand metric tons of CO2 equivalent) of PFC gas in 2005 to that in 2008?
Provide a succinct answer. 0.9. What is the ratio of the Emissions (in thousand metric tons of CO2 equivalent) in Other greenhouse gases in 2005 to that in 2010?
Your answer should be very brief. 0.81. What is the ratio of the Emissions (in thousand metric tons of CO2 equivalent) of SF6 gas in 2005 to that in 2010?
Your answer should be compact. 0.78. What is the ratio of the Emissions (in thousand metric tons of CO2 equivalent) in HFC gas in 2005 to that in 2010?
Make the answer very short. 0.54. What is the ratio of the Emissions (in thousand metric tons of CO2 equivalent) of PFC gas in 2005 to that in 2010?
Your answer should be very brief. 0.98. What is the ratio of the Emissions (in thousand metric tons of CO2 equivalent) in Other greenhouse gases in 2008 to that in 2010?
Offer a terse response. 0.97. What is the ratio of the Emissions (in thousand metric tons of CO2 equivalent) of SF6 gas in 2008 to that in 2010?
Keep it short and to the point. 0.91. What is the ratio of the Emissions (in thousand metric tons of CO2 equivalent) in HFC gas in 2008 to that in 2010?
Offer a terse response. 0.81. What is the ratio of the Emissions (in thousand metric tons of CO2 equivalent) in PFC gas in 2008 to that in 2010?
Provide a succinct answer. 1.08. What is the difference between the highest and the second highest Emissions (in thousand metric tons of CO2 equivalent) in Other greenhouse gases?
Give a very brief answer. 294.4. What is the difference between the highest and the second highest Emissions (in thousand metric tons of CO2 equivalent) in SF6 gas?
Offer a very short reply. 24.1. What is the difference between the highest and the second highest Emissions (in thousand metric tons of CO2 equivalent) in HFC gas?
Provide a succinct answer. 628.5. What is the difference between the highest and the second highest Emissions (in thousand metric tons of CO2 equivalent) in PFC gas?
Give a very brief answer. 468.8. What is the difference between the highest and the lowest Emissions (in thousand metric tons of CO2 equivalent) of Other greenhouse gases?
Keep it short and to the point. 5595.8. What is the difference between the highest and the lowest Emissions (in thousand metric tons of CO2 equivalent) in SF6 gas?
Your answer should be compact. 773.3. What is the difference between the highest and the lowest Emissions (in thousand metric tons of CO2 equivalent) in HFC gas?
Keep it short and to the point. 3188.6. What is the difference between the highest and the lowest Emissions (in thousand metric tons of CO2 equivalent) of PFC gas?
Make the answer very short. 2102.7. 